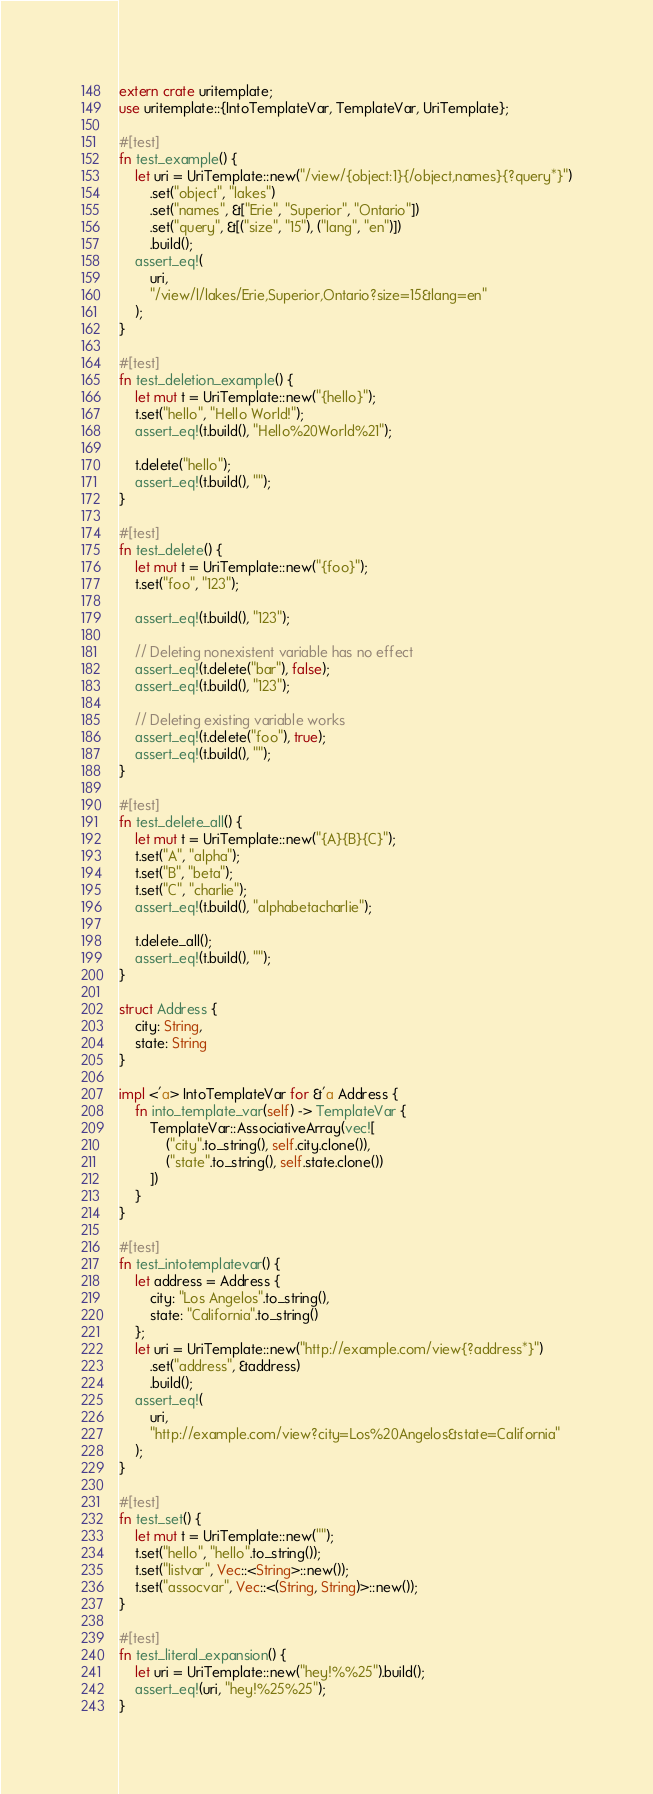Convert code to text. <code><loc_0><loc_0><loc_500><loc_500><_Rust_>extern crate uritemplate;
use uritemplate::{IntoTemplateVar, TemplateVar, UriTemplate};

#[test]
fn test_example() {
    let uri = UriTemplate::new("/view/{object:1}{/object,names}{?query*}")
        .set("object", "lakes")
        .set("names", &["Erie", "Superior", "Ontario"])
        .set("query", &[("size", "15"), ("lang", "en")])
        .build();
    assert_eq!(
        uri,
        "/view/l/lakes/Erie,Superior,Ontario?size=15&lang=en"
    );
}

#[test]
fn test_deletion_example() {
    let mut t = UriTemplate::new("{hello}");
    t.set("hello", "Hello World!");
    assert_eq!(t.build(), "Hello%20World%21");

    t.delete("hello");
    assert_eq!(t.build(), "");
}

#[test]
fn test_delete() {
    let mut t = UriTemplate::new("{foo}");
    t.set("foo", "123");

    assert_eq!(t.build(), "123");

    // Deleting nonexistent variable has no effect
    assert_eq!(t.delete("bar"), false);
    assert_eq!(t.build(), "123");

    // Deleting existing variable works
    assert_eq!(t.delete("foo"), true);
    assert_eq!(t.build(), "");
}

#[test]
fn test_delete_all() {
    let mut t = UriTemplate::new("{A}{B}{C}");
    t.set("A", "alpha");
    t.set("B", "beta");
    t.set("C", "charlie");
    assert_eq!(t.build(), "alphabetacharlie");

    t.delete_all();
    assert_eq!(t.build(), "");
}

struct Address {
    city: String,
    state: String
}

impl <'a> IntoTemplateVar for &'a Address {
    fn into_template_var(self) -> TemplateVar {
        TemplateVar::AssociativeArray(vec![
            ("city".to_string(), self.city.clone()),
            ("state".to_string(), self.state.clone())
        ])
    }
}

#[test]
fn test_intotemplatevar() {
    let address = Address {
        city: "Los Angelos".to_string(),
        state: "California".to_string()
    };
    let uri = UriTemplate::new("http://example.com/view{?address*}")
        .set("address", &address)
        .build();
    assert_eq!(
        uri,
        "http://example.com/view?city=Los%20Angelos&state=California"
    );
}

#[test]
fn test_set() {
    let mut t = UriTemplate::new("");
    t.set("hello", "hello".to_string());
    t.set("listvar", Vec::<String>::new());
    t.set("assocvar", Vec::<(String, String)>::new());
}

#[test]
fn test_literal_expansion() {
    let uri = UriTemplate::new("hey!%%25").build();
    assert_eq!(uri, "hey!%25%25");
}
</code> 